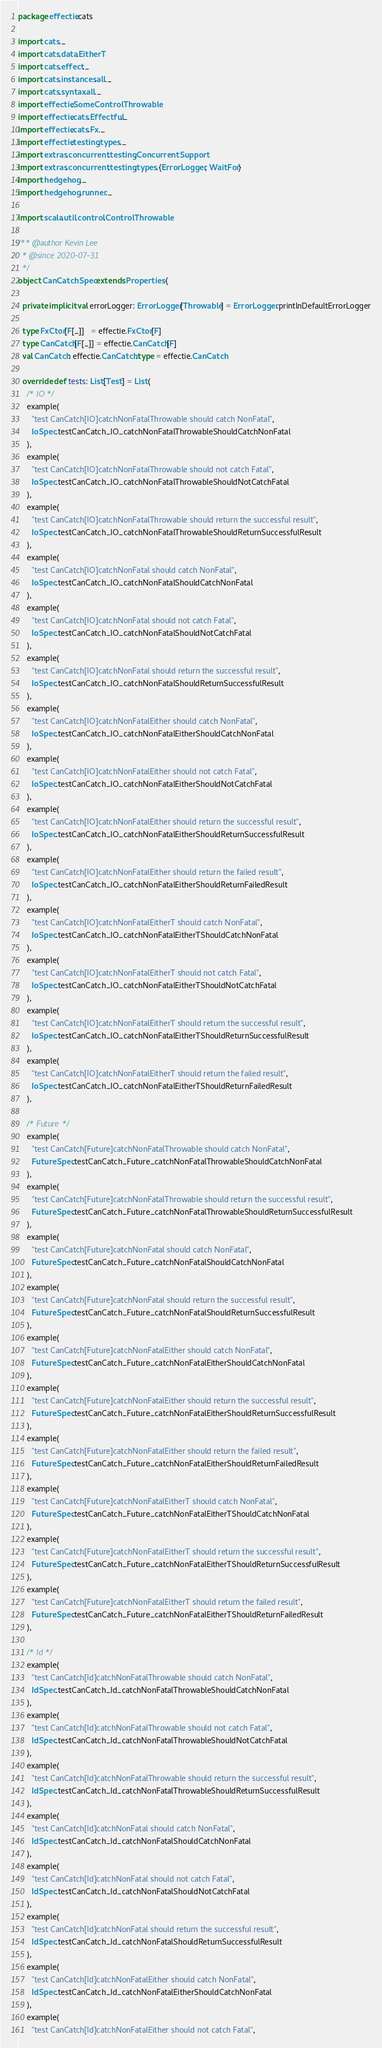Convert code to text. <code><loc_0><loc_0><loc_500><loc_500><_Scala_>package effectie.cats

import cats._
import cats.data.EitherT
import cats.effect._
import cats.instances.all._
import cats.syntax.all._
import effectie.SomeControlThrowable
import effectie.cats.Effectful._
import effectie.cats.Fx._
import effectie.testing.types._
import extras.concurrent.testing.ConcurrentSupport
import extras.concurrent.testing.types.{ErrorLogger, WaitFor}
import hedgehog._
import hedgehog.runner._

import scala.util.control.ControlThrowable

/** @author Kevin Lee
  * @since 2020-07-31
  */
object CanCatchSpec extends Properties {

  private implicit val errorLogger: ErrorLogger[Throwable] = ErrorLogger.printlnDefaultErrorLogger

  type FxCtor[F[_]]   = effectie.FxCtor[F]
  type CanCatch[F[_]] = effectie.CanCatch[F]
  val CanCatch: effectie.CanCatch.type = effectie.CanCatch

  override def tests: List[Test] = List(
    /* IO */
    example(
      "test CanCatch[IO]catchNonFatalThrowable should catch NonFatal",
      IoSpec.testCanCatch_IO_catchNonFatalThrowableShouldCatchNonFatal
    ),
    example(
      "test CanCatch[IO]catchNonFatalThrowable should not catch Fatal",
      IoSpec.testCanCatch_IO_catchNonFatalThrowableShouldNotCatchFatal
    ),
    example(
      "test CanCatch[IO]catchNonFatalThrowable should return the successful result",
      IoSpec.testCanCatch_IO_catchNonFatalThrowableShouldReturnSuccessfulResult
    ),
    example(
      "test CanCatch[IO]catchNonFatal should catch NonFatal",
      IoSpec.testCanCatch_IO_catchNonFatalShouldCatchNonFatal
    ),
    example(
      "test CanCatch[IO]catchNonFatal should not catch Fatal",
      IoSpec.testCanCatch_IO_catchNonFatalShouldNotCatchFatal
    ),
    example(
      "test CanCatch[IO]catchNonFatal should return the successful result",
      IoSpec.testCanCatch_IO_catchNonFatalShouldReturnSuccessfulResult
    ),
    example(
      "test CanCatch[IO]catchNonFatalEither should catch NonFatal",
      IoSpec.testCanCatch_IO_catchNonFatalEitherShouldCatchNonFatal
    ),
    example(
      "test CanCatch[IO]catchNonFatalEither should not catch Fatal",
      IoSpec.testCanCatch_IO_catchNonFatalEitherShouldNotCatchFatal
    ),
    example(
      "test CanCatch[IO]catchNonFatalEither should return the successful result",
      IoSpec.testCanCatch_IO_catchNonFatalEitherShouldReturnSuccessfulResult
    ),
    example(
      "test CanCatch[IO]catchNonFatalEither should return the failed result",
      IoSpec.testCanCatch_IO_catchNonFatalEitherShouldReturnFailedResult
    ),
    example(
      "test CanCatch[IO]catchNonFatalEitherT should catch NonFatal",
      IoSpec.testCanCatch_IO_catchNonFatalEitherTShouldCatchNonFatal
    ),
    example(
      "test CanCatch[IO]catchNonFatalEitherT should not catch Fatal",
      IoSpec.testCanCatch_IO_catchNonFatalEitherTShouldNotCatchFatal
    ),
    example(
      "test CanCatch[IO]catchNonFatalEitherT should return the successful result",
      IoSpec.testCanCatch_IO_catchNonFatalEitherTShouldReturnSuccessfulResult
    ),
    example(
      "test CanCatch[IO]catchNonFatalEitherT should return the failed result",
      IoSpec.testCanCatch_IO_catchNonFatalEitherTShouldReturnFailedResult
    ),

    /* Future */
    example(
      "test CanCatch[Future]catchNonFatalThrowable should catch NonFatal",
      FutureSpec.testCanCatch_Future_catchNonFatalThrowableShouldCatchNonFatal
    ),
    example(
      "test CanCatch[Future]catchNonFatalThrowable should return the successful result",
      FutureSpec.testCanCatch_Future_catchNonFatalThrowableShouldReturnSuccessfulResult
    ),
    example(
      "test CanCatch[Future]catchNonFatal should catch NonFatal",
      FutureSpec.testCanCatch_Future_catchNonFatalShouldCatchNonFatal
    ),
    example(
      "test CanCatch[Future]catchNonFatal should return the successful result",
      FutureSpec.testCanCatch_Future_catchNonFatalShouldReturnSuccessfulResult
    ),
    example(
      "test CanCatch[Future]catchNonFatalEither should catch NonFatal",
      FutureSpec.testCanCatch_Future_catchNonFatalEitherShouldCatchNonFatal
    ),
    example(
      "test CanCatch[Future]catchNonFatalEither should return the successful result",
      FutureSpec.testCanCatch_Future_catchNonFatalEitherShouldReturnSuccessfulResult
    ),
    example(
      "test CanCatch[Future]catchNonFatalEither should return the failed result",
      FutureSpec.testCanCatch_Future_catchNonFatalEitherShouldReturnFailedResult
    ),
    example(
      "test CanCatch[Future]catchNonFatalEitherT should catch NonFatal",
      FutureSpec.testCanCatch_Future_catchNonFatalEitherTShouldCatchNonFatal
    ),
    example(
      "test CanCatch[Future]catchNonFatalEitherT should return the successful result",
      FutureSpec.testCanCatch_Future_catchNonFatalEitherTShouldReturnSuccessfulResult
    ),
    example(
      "test CanCatch[Future]catchNonFatalEitherT should return the failed result",
      FutureSpec.testCanCatch_Future_catchNonFatalEitherTShouldReturnFailedResult
    ),

    /* Id */
    example(
      "test CanCatch[Id]catchNonFatalThrowable should catch NonFatal",
      IdSpec.testCanCatch_Id_catchNonFatalThrowableShouldCatchNonFatal
    ),
    example(
      "test CanCatch[Id]catchNonFatalThrowable should not catch Fatal",
      IdSpec.testCanCatch_Id_catchNonFatalThrowableShouldNotCatchFatal
    ),
    example(
      "test CanCatch[Id]catchNonFatalThrowable should return the successful result",
      IdSpec.testCanCatch_Id_catchNonFatalThrowableShouldReturnSuccessfulResult
    ),
    example(
      "test CanCatch[Id]catchNonFatal should catch NonFatal",
      IdSpec.testCanCatch_Id_catchNonFatalShouldCatchNonFatal
    ),
    example(
      "test CanCatch[Id]catchNonFatal should not catch Fatal",
      IdSpec.testCanCatch_Id_catchNonFatalShouldNotCatchFatal
    ),
    example(
      "test CanCatch[Id]catchNonFatal should return the successful result",
      IdSpec.testCanCatch_Id_catchNonFatalShouldReturnSuccessfulResult
    ),
    example(
      "test CanCatch[Id]catchNonFatalEither should catch NonFatal",
      IdSpec.testCanCatch_Id_catchNonFatalEitherShouldCatchNonFatal
    ),
    example(
      "test CanCatch[Id]catchNonFatalEither should not catch Fatal",</code> 